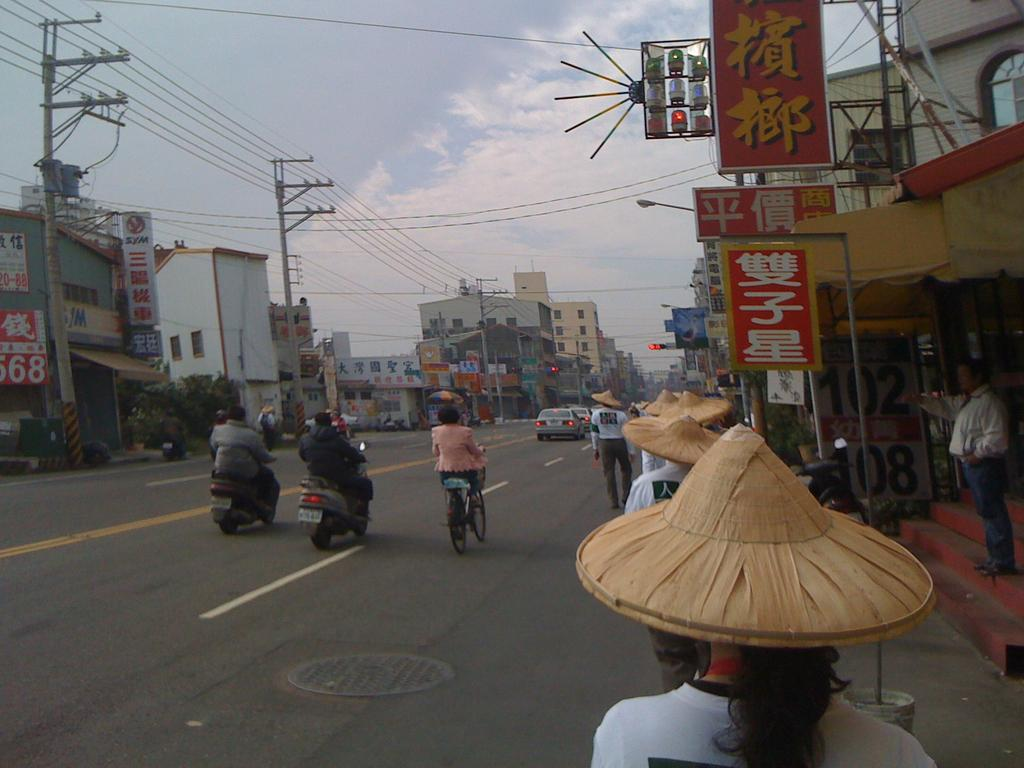Provide a one-sentence caption for the provided image. Three people on scooters are about to pass the SYM business on their left. 